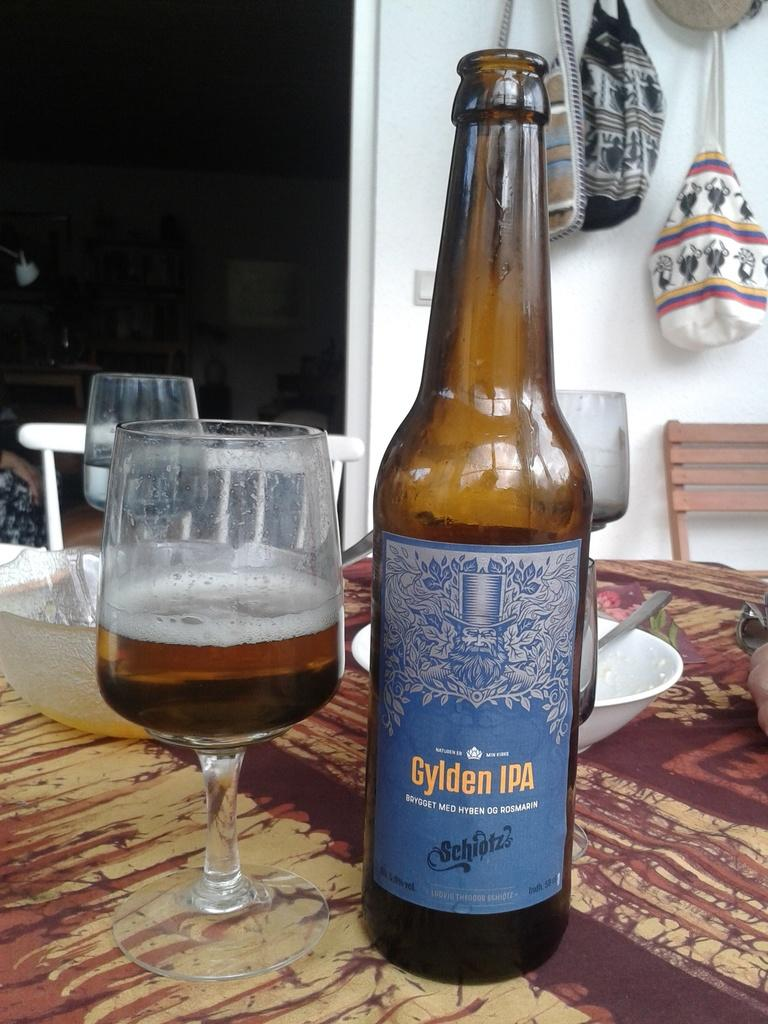What is one of the objects on the table in the image? There is a bottle in the image. What is another object on the table that contains a drink? There is a glass with a drink in the image. What is the third object on the table that can be used for eating? There is a bowl in the image. What utensil is present in the image that can be used with the bowl? There is a spoon in the image. Where are the objects located in the image? The objects are on a table. What can be seen in the background of the image? There are chairs, a bag, and a wall in the background of the image. How would you describe the lighting in the background of the image? The background is dark. What type of brain is visible in the image? There is no brain present in the image. What condition is the system in, as seen in the image? There is no system or condition mentioned in the image. 